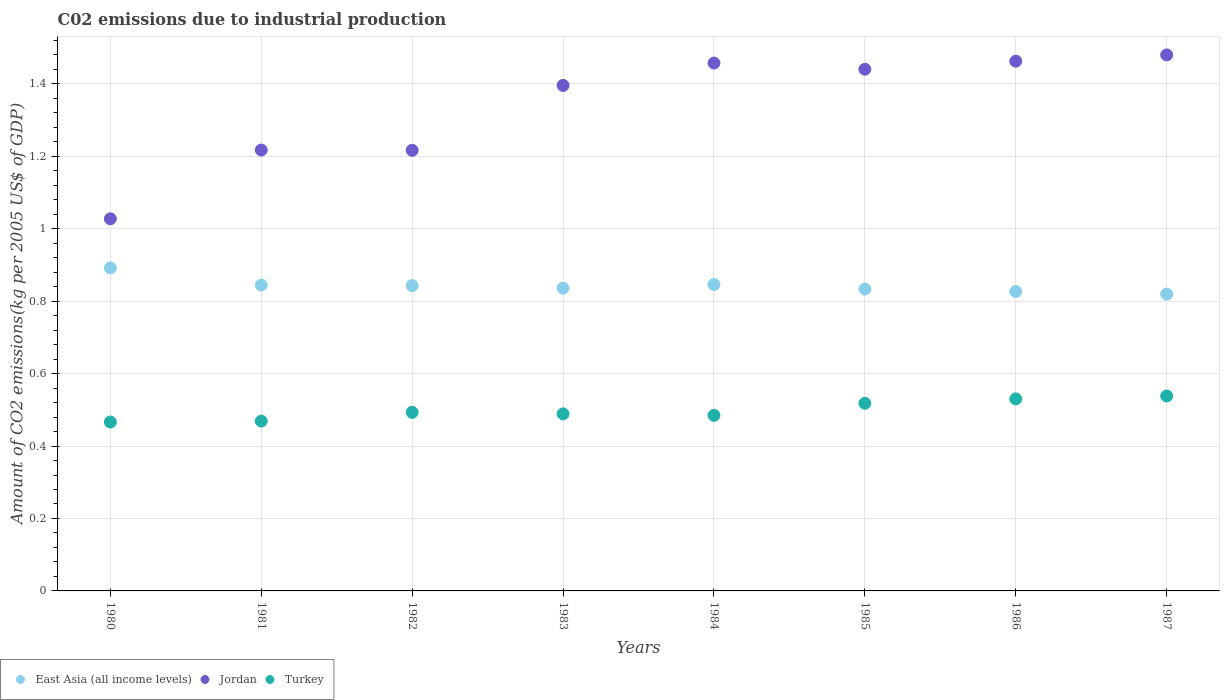How many different coloured dotlines are there?
Your answer should be very brief. 3. Is the number of dotlines equal to the number of legend labels?
Your response must be concise. Yes. What is the amount of CO2 emitted due to industrial production in Jordan in 1983?
Your answer should be very brief. 1.4. Across all years, what is the maximum amount of CO2 emitted due to industrial production in East Asia (all income levels)?
Offer a very short reply. 0.89. Across all years, what is the minimum amount of CO2 emitted due to industrial production in East Asia (all income levels)?
Make the answer very short. 0.82. In which year was the amount of CO2 emitted due to industrial production in Turkey minimum?
Provide a succinct answer. 1980. What is the total amount of CO2 emitted due to industrial production in Jordan in the graph?
Keep it short and to the point. 10.7. What is the difference between the amount of CO2 emitted due to industrial production in East Asia (all income levels) in 1982 and that in 1983?
Your response must be concise. 0.01. What is the difference between the amount of CO2 emitted due to industrial production in Jordan in 1986 and the amount of CO2 emitted due to industrial production in Turkey in 1980?
Make the answer very short. 1. What is the average amount of CO2 emitted due to industrial production in East Asia (all income levels) per year?
Provide a succinct answer. 0.84. In the year 1983, what is the difference between the amount of CO2 emitted due to industrial production in Jordan and amount of CO2 emitted due to industrial production in Turkey?
Offer a terse response. 0.91. What is the ratio of the amount of CO2 emitted due to industrial production in East Asia (all income levels) in 1982 to that in 1983?
Your answer should be compact. 1.01. What is the difference between the highest and the second highest amount of CO2 emitted due to industrial production in Jordan?
Provide a succinct answer. 0.02. What is the difference between the highest and the lowest amount of CO2 emitted due to industrial production in Jordan?
Give a very brief answer. 0.45. In how many years, is the amount of CO2 emitted due to industrial production in Jordan greater than the average amount of CO2 emitted due to industrial production in Jordan taken over all years?
Your answer should be very brief. 5. Does the amount of CO2 emitted due to industrial production in East Asia (all income levels) monotonically increase over the years?
Provide a succinct answer. No. Is the amount of CO2 emitted due to industrial production in East Asia (all income levels) strictly greater than the amount of CO2 emitted due to industrial production in Turkey over the years?
Keep it short and to the point. Yes. Is the amount of CO2 emitted due to industrial production in Turkey strictly less than the amount of CO2 emitted due to industrial production in Jordan over the years?
Ensure brevity in your answer.  Yes. Does the graph contain any zero values?
Ensure brevity in your answer.  No. Where does the legend appear in the graph?
Your answer should be very brief. Bottom left. How are the legend labels stacked?
Give a very brief answer. Horizontal. What is the title of the graph?
Your answer should be very brief. C02 emissions due to industrial production. What is the label or title of the Y-axis?
Offer a very short reply. Amount of CO2 emissions(kg per 2005 US$ of GDP). What is the Amount of CO2 emissions(kg per 2005 US$ of GDP) in East Asia (all income levels) in 1980?
Offer a terse response. 0.89. What is the Amount of CO2 emissions(kg per 2005 US$ of GDP) of Jordan in 1980?
Make the answer very short. 1.03. What is the Amount of CO2 emissions(kg per 2005 US$ of GDP) in Turkey in 1980?
Keep it short and to the point. 0.47. What is the Amount of CO2 emissions(kg per 2005 US$ of GDP) of East Asia (all income levels) in 1981?
Provide a succinct answer. 0.84. What is the Amount of CO2 emissions(kg per 2005 US$ of GDP) in Jordan in 1981?
Offer a very short reply. 1.22. What is the Amount of CO2 emissions(kg per 2005 US$ of GDP) in Turkey in 1981?
Offer a very short reply. 0.47. What is the Amount of CO2 emissions(kg per 2005 US$ of GDP) of East Asia (all income levels) in 1982?
Offer a terse response. 0.84. What is the Amount of CO2 emissions(kg per 2005 US$ of GDP) in Jordan in 1982?
Provide a succinct answer. 1.22. What is the Amount of CO2 emissions(kg per 2005 US$ of GDP) in Turkey in 1982?
Make the answer very short. 0.49. What is the Amount of CO2 emissions(kg per 2005 US$ of GDP) of East Asia (all income levels) in 1983?
Ensure brevity in your answer.  0.84. What is the Amount of CO2 emissions(kg per 2005 US$ of GDP) of Jordan in 1983?
Offer a very short reply. 1.4. What is the Amount of CO2 emissions(kg per 2005 US$ of GDP) in Turkey in 1983?
Provide a short and direct response. 0.49. What is the Amount of CO2 emissions(kg per 2005 US$ of GDP) in East Asia (all income levels) in 1984?
Ensure brevity in your answer.  0.85. What is the Amount of CO2 emissions(kg per 2005 US$ of GDP) in Jordan in 1984?
Make the answer very short. 1.46. What is the Amount of CO2 emissions(kg per 2005 US$ of GDP) in Turkey in 1984?
Provide a succinct answer. 0.48. What is the Amount of CO2 emissions(kg per 2005 US$ of GDP) in East Asia (all income levels) in 1985?
Keep it short and to the point. 0.83. What is the Amount of CO2 emissions(kg per 2005 US$ of GDP) of Jordan in 1985?
Make the answer very short. 1.44. What is the Amount of CO2 emissions(kg per 2005 US$ of GDP) of Turkey in 1985?
Your answer should be very brief. 0.52. What is the Amount of CO2 emissions(kg per 2005 US$ of GDP) in East Asia (all income levels) in 1986?
Your answer should be compact. 0.83. What is the Amount of CO2 emissions(kg per 2005 US$ of GDP) in Jordan in 1986?
Provide a succinct answer. 1.46. What is the Amount of CO2 emissions(kg per 2005 US$ of GDP) in Turkey in 1986?
Offer a very short reply. 0.53. What is the Amount of CO2 emissions(kg per 2005 US$ of GDP) in East Asia (all income levels) in 1987?
Your answer should be compact. 0.82. What is the Amount of CO2 emissions(kg per 2005 US$ of GDP) of Jordan in 1987?
Your answer should be compact. 1.48. What is the Amount of CO2 emissions(kg per 2005 US$ of GDP) of Turkey in 1987?
Offer a very short reply. 0.54. Across all years, what is the maximum Amount of CO2 emissions(kg per 2005 US$ of GDP) of East Asia (all income levels)?
Offer a very short reply. 0.89. Across all years, what is the maximum Amount of CO2 emissions(kg per 2005 US$ of GDP) in Jordan?
Offer a terse response. 1.48. Across all years, what is the maximum Amount of CO2 emissions(kg per 2005 US$ of GDP) in Turkey?
Offer a terse response. 0.54. Across all years, what is the minimum Amount of CO2 emissions(kg per 2005 US$ of GDP) of East Asia (all income levels)?
Your response must be concise. 0.82. Across all years, what is the minimum Amount of CO2 emissions(kg per 2005 US$ of GDP) of Jordan?
Give a very brief answer. 1.03. Across all years, what is the minimum Amount of CO2 emissions(kg per 2005 US$ of GDP) in Turkey?
Provide a succinct answer. 0.47. What is the total Amount of CO2 emissions(kg per 2005 US$ of GDP) in East Asia (all income levels) in the graph?
Offer a very short reply. 6.74. What is the total Amount of CO2 emissions(kg per 2005 US$ of GDP) of Jordan in the graph?
Provide a succinct answer. 10.7. What is the total Amount of CO2 emissions(kg per 2005 US$ of GDP) of Turkey in the graph?
Provide a short and direct response. 3.99. What is the difference between the Amount of CO2 emissions(kg per 2005 US$ of GDP) of East Asia (all income levels) in 1980 and that in 1981?
Your answer should be very brief. 0.05. What is the difference between the Amount of CO2 emissions(kg per 2005 US$ of GDP) of Jordan in 1980 and that in 1981?
Your answer should be compact. -0.19. What is the difference between the Amount of CO2 emissions(kg per 2005 US$ of GDP) in Turkey in 1980 and that in 1981?
Keep it short and to the point. -0. What is the difference between the Amount of CO2 emissions(kg per 2005 US$ of GDP) in East Asia (all income levels) in 1980 and that in 1982?
Your response must be concise. 0.05. What is the difference between the Amount of CO2 emissions(kg per 2005 US$ of GDP) of Jordan in 1980 and that in 1982?
Make the answer very short. -0.19. What is the difference between the Amount of CO2 emissions(kg per 2005 US$ of GDP) in Turkey in 1980 and that in 1982?
Your response must be concise. -0.03. What is the difference between the Amount of CO2 emissions(kg per 2005 US$ of GDP) of East Asia (all income levels) in 1980 and that in 1983?
Your answer should be compact. 0.06. What is the difference between the Amount of CO2 emissions(kg per 2005 US$ of GDP) in Jordan in 1980 and that in 1983?
Keep it short and to the point. -0.37. What is the difference between the Amount of CO2 emissions(kg per 2005 US$ of GDP) in Turkey in 1980 and that in 1983?
Your answer should be very brief. -0.02. What is the difference between the Amount of CO2 emissions(kg per 2005 US$ of GDP) in East Asia (all income levels) in 1980 and that in 1984?
Make the answer very short. 0.05. What is the difference between the Amount of CO2 emissions(kg per 2005 US$ of GDP) in Jordan in 1980 and that in 1984?
Provide a short and direct response. -0.43. What is the difference between the Amount of CO2 emissions(kg per 2005 US$ of GDP) of Turkey in 1980 and that in 1984?
Offer a very short reply. -0.02. What is the difference between the Amount of CO2 emissions(kg per 2005 US$ of GDP) of East Asia (all income levels) in 1980 and that in 1985?
Ensure brevity in your answer.  0.06. What is the difference between the Amount of CO2 emissions(kg per 2005 US$ of GDP) of Jordan in 1980 and that in 1985?
Ensure brevity in your answer.  -0.41. What is the difference between the Amount of CO2 emissions(kg per 2005 US$ of GDP) in Turkey in 1980 and that in 1985?
Your answer should be very brief. -0.05. What is the difference between the Amount of CO2 emissions(kg per 2005 US$ of GDP) in East Asia (all income levels) in 1980 and that in 1986?
Provide a short and direct response. 0.07. What is the difference between the Amount of CO2 emissions(kg per 2005 US$ of GDP) in Jordan in 1980 and that in 1986?
Offer a very short reply. -0.44. What is the difference between the Amount of CO2 emissions(kg per 2005 US$ of GDP) in Turkey in 1980 and that in 1986?
Offer a very short reply. -0.06. What is the difference between the Amount of CO2 emissions(kg per 2005 US$ of GDP) of East Asia (all income levels) in 1980 and that in 1987?
Your response must be concise. 0.07. What is the difference between the Amount of CO2 emissions(kg per 2005 US$ of GDP) in Jordan in 1980 and that in 1987?
Ensure brevity in your answer.  -0.45. What is the difference between the Amount of CO2 emissions(kg per 2005 US$ of GDP) of Turkey in 1980 and that in 1987?
Ensure brevity in your answer.  -0.07. What is the difference between the Amount of CO2 emissions(kg per 2005 US$ of GDP) of East Asia (all income levels) in 1981 and that in 1982?
Offer a terse response. 0. What is the difference between the Amount of CO2 emissions(kg per 2005 US$ of GDP) of Jordan in 1981 and that in 1982?
Offer a terse response. 0. What is the difference between the Amount of CO2 emissions(kg per 2005 US$ of GDP) of Turkey in 1981 and that in 1982?
Your answer should be compact. -0.02. What is the difference between the Amount of CO2 emissions(kg per 2005 US$ of GDP) of East Asia (all income levels) in 1981 and that in 1983?
Make the answer very short. 0.01. What is the difference between the Amount of CO2 emissions(kg per 2005 US$ of GDP) in Jordan in 1981 and that in 1983?
Provide a succinct answer. -0.18. What is the difference between the Amount of CO2 emissions(kg per 2005 US$ of GDP) of Turkey in 1981 and that in 1983?
Your answer should be compact. -0.02. What is the difference between the Amount of CO2 emissions(kg per 2005 US$ of GDP) in East Asia (all income levels) in 1981 and that in 1984?
Your response must be concise. -0. What is the difference between the Amount of CO2 emissions(kg per 2005 US$ of GDP) of Jordan in 1981 and that in 1984?
Offer a very short reply. -0.24. What is the difference between the Amount of CO2 emissions(kg per 2005 US$ of GDP) of Turkey in 1981 and that in 1984?
Provide a short and direct response. -0.02. What is the difference between the Amount of CO2 emissions(kg per 2005 US$ of GDP) in East Asia (all income levels) in 1981 and that in 1985?
Give a very brief answer. 0.01. What is the difference between the Amount of CO2 emissions(kg per 2005 US$ of GDP) in Jordan in 1981 and that in 1985?
Your answer should be very brief. -0.22. What is the difference between the Amount of CO2 emissions(kg per 2005 US$ of GDP) in Turkey in 1981 and that in 1985?
Offer a terse response. -0.05. What is the difference between the Amount of CO2 emissions(kg per 2005 US$ of GDP) in East Asia (all income levels) in 1981 and that in 1986?
Ensure brevity in your answer.  0.02. What is the difference between the Amount of CO2 emissions(kg per 2005 US$ of GDP) in Jordan in 1981 and that in 1986?
Ensure brevity in your answer.  -0.25. What is the difference between the Amount of CO2 emissions(kg per 2005 US$ of GDP) of Turkey in 1981 and that in 1986?
Ensure brevity in your answer.  -0.06. What is the difference between the Amount of CO2 emissions(kg per 2005 US$ of GDP) of East Asia (all income levels) in 1981 and that in 1987?
Provide a succinct answer. 0.02. What is the difference between the Amount of CO2 emissions(kg per 2005 US$ of GDP) in Jordan in 1981 and that in 1987?
Offer a very short reply. -0.26. What is the difference between the Amount of CO2 emissions(kg per 2005 US$ of GDP) in Turkey in 1981 and that in 1987?
Your answer should be compact. -0.07. What is the difference between the Amount of CO2 emissions(kg per 2005 US$ of GDP) in East Asia (all income levels) in 1982 and that in 1983?
Your answer should be very brief. 0.01. What is the difference between the Amount of CO2 emissions(kg per 2005 US$ of GDP) in Jordan in 1982 and that in 1983?
Your response must be concise. -0.18. What is the difference between the Amount of CO2 emissions(kg per 2005 US$ of GDP) of Turkey in 1982 and that in 1983?
Keep it short and to the point. 0. What is the difference between the Amount of CO2 emissions(kg per 2005 US$ of GDP) of East Asia (all income levels) in 1982 and that in 1984?
Offer a very short reply. -0. What is the difference between the Amount of CO2 emissions(kg per 2005 US$ of GDP) of Jordan in 1982 and that in 1984?
Your answer should be very brief. -0.24. What is the difference between the Amount of CO2 emissions(kg per 2005 US$ of GDP) of Turkey in 1982 and that in 1984?
Keep it short and to the point. 0.01. What is the difference between the Amount of CO2 emissions(kg per 2005 US$ of GDP) of East Asia (all income levels) in 1982 and that in 1985?
Your response must be concise. 0.01. What is the difference between the Amount of CO2 emissions(kg per 2005 US$ of GDP) of Jordan in 1982 and that in 1985?
Your response must be concise. -0.22. What is the difference between the Amount of CO2 emissions(kg per 2005 US$ of GDP) of Turkey in 1982 and that in 1985?
Your answer should be very brief. -0.03. What is the difference between the Amount of CO2 emissions(kg per 2005 US$ of GDP) in East Asia (all income levels) in 1982 and that in 1986?
Your answer should be very brief. 0.02. What is the difference between the Amount of CO2 emissions(kg per 2005 US$ of GDP) in Jordan in 1982 and that in 1986?
Offer a terse response. -0.25. What is the difference between the Amount of CO2 emissions(kg per 2005 US$ of GDP) in Turkey in 1982 and that in 1986?
Your answer should be very brief. -0.04. What is the difference between the Amount of CO2 emissions(kg per 2005 US$ of GDP) in East Asia (all income levels) in 1982 and that in 1987?
Your answer should be very brief. 0.02. What is the difference between the Amount of CO2 emissions(kg per 2005 US$ of GDP) of Jordan in 1982 and that in 1987?
Your answer should be compact. -0.26. What is the difference between the Amount of CO2 emissions(kg per 2005 US$ of GDP) of Turkey in 1982 and that in 1987?
Provide a short and direct response. -0.05. What is the difference between the Amount of CO2 emissions(kg per 2005 US$ of GDP) in East Asia (all income levels) in 1983 and that in 1984?
Provide a succinct answer. -0.01. What is the difference between the Amount of CO2 emissions(kg per 2005 US$ of GDP) in Jordan in 1983 and that in 1984?
Provide a succinct answer. -0.06. What is the difference between the Amount of CO2 emissions(kg per 2005 US$ of GDP) of Turkey in 1983 and that in 1984?
Provide a short and direct response. 0. What is the difference between the Amount of CO2 emissions(kg per 2005 US$ of GDP) in East Asia (all income levels) in 1983 and that in 1985?
Give a very brief answer. 0. What is the difference between the Amount of CO2 emissions(kg per 2005 US$ of GDP) of Jordan in 1983 and that in 1985?
Your answer should be compact. -0.04. What is the difference between the Amount of CO2 emissions(kg per 2005 US$ of GDP) in Turkey in 1983 and that in 1985?
Offer a very short reply. -0.03. What is the difference between the Amount of CO2 emissions(kg per 2005 US$ of GDP) of East Asia (all income levels) in 1983 and that in 1986?
Offer a very short reply. 0.01. What is the difference between the Amount of CO2 emissions(kg per 2005 US$ of GDP) of Jordan in 1983 and that in 1986?
Offer a terse response. -0.07. What is the difference between the Amount of CO2 emissions(kg per 2005 US$ of GDP) of Turkey in 1983 and that in 1986?
Make the answer very short. -0.04. What is the difference between the Amount of CO2 emissions(kg per 2005 US$ of GDP) of East Asia (all income levels) in 1983 and that in 1987?
Offer a very short reply. 0.02. What is the difference between the Amount of CO2 emissions(kg per 2005 US$ of GDP) of Jordan in 1983 and that in 1987?
Your answer should be very brief. -0.08. What is the difference between the Amount of CO2 emissions(kg per 2005 US$ of GDP) of Turkey in 1983 and that in 1987?
Provide a succinct answer. -0.05. What is the difference between the Amount of CO2 emissions(kg per 2005 US$ of GDP) of East Asia (all income levels) in 1984 and that in 1985?
Give a very brief answer. 0.01. What is the difference between the Amount of CO2 emissions(kg per 2005 US$ of GDP) in Jordan in 1984 and that in 1985?
Provide a short and direct response. 0.02. What is the difference between the Amount of CO2 emissions(kg per 2005 US$ of GDP) in Turkey in 1984 and that in 1985?
Offer a terse response. -0.03. What is the difference between the Amount of CO2 emissions(kg per 2005 US$ of GDP) in East Asia (all income levels) in 1984 and that in 1986?
Give a very brief answer. 0.02. What is the difference between the Amount of CO2 emissions(kg per 2005 US$ of GDP) of Jordan in 1984 and that in 1986?
Your answer should be compact. -0.01. What is the difference between the Amount of CO2 emissions(kg per 2005 US$ of GDP) in Turkey in 1984 and that in 1986?
Your answer should be compact. -0.05. What is the difference between the Amount of CO2 emissions(kg per 2005 US$ of GDP) in East Asia (all income levels) in 1984 and that in 1987?
Your response must be concise. 0.03. What is the difference between the Amount of CO2 emissions(kg per 2005 US$ of GDP) in Jordan in 1984 and that in 1987?
Your answer should be very brief. -0.02. What is the difference between the Amount of CO2 emissions(kg per 2005 US$ of GDP) of Turkey in 1984 and that in 1987?
Your response must be concise. -0.05. What is the difference between the Amount of CO2 emissions(kg per 2005 US$ of GDP) in East Asia (all income levels) in 1985 and that in 1986?
Offer a very short reply. 0.01. What is the difference between the Amount of CO2 emissions(kg per 2005 US$ of GDP) in Jordan in 1985 and that in 1986?
Your response must be concise. -0.02. What is the difference between the Amount of CO2 emissions(kg per 2005 US$ of GDP) of Turkey in 1985 and that in 1986?
Ensure brevity in your answer.  -0.01. What is the difference between the Amount of CO2 emissions(kg per 2005 US$ of GDP) of East Asia (all income levels) in 1985 and that in 1987?
Make the answer very short. 0.01. What is the difference between the Amount of CO2 emissions(kg per 2005 US$ of GDP) in Jordan in 1985 and that in 1987?
Keep it short and to the point. -0.04. What is the difference between the Amount of CO2 emissions(kg per 2005 US$ of GDP) in Turkey in 1985 and that in 1987?
Give a very brief answer. -0.02. What is the difference between the Amount of CO2 emissions(kg per 2005 US$ of GDP) in East Asia (all income levels) in 1986 and that in 1987?
Give a very brief answer. 0.01. What is the difference between the Amount of CO2 emissions(kg per 2005 US$ of GDP) of Jordan in 1986 and that in 1987?
Give a very brief answer. -0.02. What is the difference between the Amount of CO2 emissions(kg per 2005 US$ of GDP) in Turkey in 1986 and that in 1987?
Your answer should be very brief. -0.01. What is the difference between the Amount of CO2 emissions(kg per 2005 US$ of GDP) of East Asia (all income levels) in 1980 and the Amount of CO2 emissions(kg per 2005 US$ of GDP) of Jordan in 1981?
Give a very brief answer. -0.33. What is the difference between the Amount of CO2 emissions(kg per 2005 US$ of GDP) of East Asia (all income levels) in 1980 and the Amount of CO2 emissions(kg per 2005 US$ of GDP) of Turkey in 1981?
Provide a succinct answer. 0.42. What is the difference between the Amount of CO2 emissions(kg per 2005 US$ of GDP) in Jordan in 1980 and the Amount of CO2 emissions(kg per 2005 US$ of GDP) in Turkey in 1981?
Ensure brevity in your answer.  0.56. What is the difference between the Amount of CO2 emissions(kg per 2005 US$ of GDP) in East Asia (all income levels) in 1980 and the Amount of CO2 emissions(kg per 2005 US$ of GDP) in Jordan in 1982?
Your answer should be very brief. -0.32. What is the difference between the Amount of CO2 emissions(kg per 2005 US$ of GDP) of East Asia (all income levels) in 1980 and the Amount of CO2 emissions(kg per 2005 US$ of GDP) of Turkey in 1982?
Give a very brief answer. 0.4. What is the difference between the Amount of CO2 emissions(kg per 2005 US$ of GDP) of Jordan in 1980 and the Amount of CO2 emissions(kg per 2005 US$ of GDP) of Turkey in 1982?
Your response must be concise. 0.53. What is the difference between the Amount of CO2 emissions(kg per 2005 US$ of GDP) in East Asia (all income levels) in 1980 and the Amount of CO2 emissions(kg per 2005 US$ of GDP) in Jordan in 1983?
Your answer should be very brief. -0.5. What is the difference between the Amount of CO2 emissions(kg per 2005 US$ of GDP) in East Asia (all income levels) in 1980 and the Amount of CO2 emissions(kg per 2005 US$ of GDP) in Turkey in 1983?
Ensure brevity in your answer.  0.4. What is the difference between the Amount of CO2 emissions(kg per 2005 US$ of GDP) in Jordan in 1980 and the Amount of CO2 emissions(kg per 2005 US$ of GDP) in Turkey in 1983?
Your answer should be compact. 0.54. What is the difference between the Amount of CO2 emissions(kg per 2005 US$ of GDP) of East Asia (all income levels) in 1980 and the Amount of CO2 emissions(kg per 2005 US$ of GDP) of Jordan in 1984?
Offer a terse response. -0.57. What is the difference between the Amount of CO2 emissions(kg per 2005 US$ of GDP) of East Asia (all income levels) in 1980 and the Amount of CO2 emissions(kg per 2005 US$ of GDP) of Turkey in 1984?
Keep it short and to the point. 0.41. What is the difference between the Amount of CO2 emissions(kg per 2005 US$ of GDP) in Jordan in 1980 and the Amount of CO2 emissions(kg per 2005 US$ of GDP) in Turkey in 1984?
Provide a short and direct response. 0.54. What is the difference between the Amount of CO2 emissions(kg per 2005 US$ of GDP) of East Asia (all income levels) in 1980 and the Amount of CO2 emissions(kg per 2005 US$ of GDP) of Jordan in 1985?
Give a very brief answer. -0.55. What is the difference between the Amount of CO2 emissions(kg per 2005 US$ of GDP) in East Asia (all income levels) in 1980 and the Amount of CO2 emissions(kg per 2005 US$ of GDP) in Turkey in 1985?
Your answer should be compact. 0.37. What is the difference between the Amount of CO2 emissions(kg per 2005 US$ of GDP) in Jordan in 1980 and the Amount of CO2 emissions(kg per 2005 US$ of GDP) in Turkey in 1985?
Your answer should be very brief. 0.51. What is the difference between the Amount of CO2 emissions(kg per 2005 US$ of GDP) of East Asia (all income levels) in 1980 and the Amount of CO2 emissions(kg per 2005 US$ of GDP) of Jordan in 1986?
Your answer should be very brief. -0.57. What is the difference between the Amount of CO2 emissions(kg per 2005 US$ of GDP) of East Asia (all income levels) in 1980 and the Amount of CO2 emissions(kg per 2005 US$ of GDP) of Turkey in 1986?
Your answer should be very brief. 0.36. What is the difference between the Amount of CO2 emissions(kg per 2005 US$ of GDP) in Jordan in 1980 and the Amount of CO2 emissions(kg per 2005 US$ of GDP) in Turkey in 1986?
Provide a succinct answer. 0.5. What is the difference between the Amount of CO2 emissions(kg per 2005 US$ of GDP) in East Asia (all income levels) in 1980 and the Amount of CO2 emissions(kg per 2005 US$ of GDP) in Jordan in 1987?
Make the answer very short. -0.59. What is the difference between the Amount of CO2 emissions(kg per 2005 US$ of GDP) of East Asia (all income levels) in 1980 and the Amount of CO2 emissions(kg per 2005 US$ of GDP) of Turkey in 1987?
Your answer should be compact. 0.35. What is the difference between the Amount of CO2 emissions(kg per 2005 US$ of GDP) of Jordan in 1980 and the Amount of CO2 emissions(kg per 2005 US$ of GDP) of Turkey in 1987?
Your answer should be compact. 0.49. What is the difference between the Amount of CO2 emissions(kg per 2005 US$ of GDP) in East Asia (all income levels) in 1981 and the Amount of CO2 emissions(kg per 2005 US$ of GDP) in Jordan in 1982?
Ensure brevity in your answer.  -0.37. What is the difference between the Amount of CO2 emissions(kg per 2005 US$ of GDP) of East Asia (all income levels) in 1981 and the Amount of CO2 emissions(kg per 2005 US$ of GDP) of Turkey in 1982?
Ensure brevity in your answer.  0.35. What is the difference between the Amount of CO2 emissions(kg per 2005 US$ of GDP) in Jordan in 1981 and the Amount of CO2 emissions(kg per 2005 US$ of GDP) in Turkey in 1982?
Your answer should be very brief. 0.72. What is the difference between the Amount of CO2 emissions(kg per 2005 US$ of GDP) in East Asia (all income levels) in 1981 and the Amount of CO2 emissions(kg per 2005 US$ of GDP) in Jordan in 1983?
Give a very brief answer. -0.55. What is the difference between the Amount of CO2 emissions(kg per 2005 US$ of GDP) of East Asia (all income levels) in 1981 and the Amount of CO2 emissions(kg per 2005 US$ of GDP) of Turkey in 1983?
Keep it short and to the point. 0.36. What is the difference between the Amount of CO2 emissions(kg per 2005 US$ of GDP) of Jordan in 1981 and the Amount of CO2 emissions(kg per 2005 US$ of GDP) of Turkey in 1983?
Ensure brevity in your answer.  0.73. What is the difference between the Amount of CO2 emissions(kg per 2005 US$ of GDP) of East Asia (all income levels) in 1981 and the Amount of CO2 emissions(kg per 2005 US$ of GDP) of Jordan in 1984?
Offer a very short reply. -0.61. What is the difference between the Amount of CO2 emissions(kg per 2005 US$ of GDP) in East Asia (all income levels) in 1981 and the Amount of CO2 emissions(kg per 2005 US$ of GDP) in Turkey in 1984?
Provide a succinct answer. 0.36. What is the difference between the Amount of CO2 emissions(kg per 2005 US$ of GDP) in Jordan in 1981 and the Amount of CO2 emissions(kg per 2005 US$ of GDP) in Turkey in 1984?
Give a very brief answer. 0.73. What is the difference between the Amount of CO2 emissions(kg per 2005 US$ of GDP) of East Asia (all income levels) in 1981 and the Amount of CO2 emissions(kg per 2005 US$ of GDP) of Jordan in 1985?
Provide a short and direct response. -0.6. What is the difference between the Amount of CO2 emissions(kg per 2005 US$ of GDP) in East Asia (all income levels) in 1981 and the Amount of CO2 emissions(kg per 2005 US$ of GDP) in Turkey in 1985?
Keep it short and to the point. 0.33. What is the difference between the Amount of CO2 emissions(kg per 2005 US$ of GDP) of Jordan in 1981 and the Amount of CO2 emissions(kg per 2005 US$ of GDP) of Turkey in 1985?
Keep it short and to the point. 0.7. What is the difference between the Amount of CO2 emissions(kg per 2005 US$ of GDP) of East Asia (all income levels) in 1981 and the Amount of CO2 emissions(kg per 2005 US$ of GDP) of Jordan in 1986?
Your answer should be compact. -0.62. What is the difference between the Amount of CO2 emissions(kg per 2005 US$ of GDP) of East Asia (all income levels) in 1981 and the Amount of CO2 emissions(kg per 2005 US$ of GDP) of Turkey in 1986?
Give a very brief answer. 0.31. What is the difference between the Amount of CO2 emissions(kg per 2005 US$ of GDP) of Jordan in 1981 and the Amount of CO2 emissions(kg per 2005 US$ of GDP) of Turkey in 1986?
Ensure brevity in your answer.  0.69. What is the difference between the Amount of CO2 emissions(kg per 2005 US$ of GDP) in East Asia (all income levels) in 1981 and the Amount of CO2 emissions(kg per 2005 US$ of GDP) in Jordan in 1987?
Your response must be concise. -0.64. What is the difference between the Amount of CO2 emissions(kg per 2005 US$ of GDP) of East Asia (all income levels) in 1981 and the Amount of CO2 emissions(kg per 2005 US$ of GDP) of Turkey in 1987?
Your answer should be very brief. 0.31. What is the difference between the Amount of CO2 emissions(kg per 2005 US$ of GDP) in Jordan in 1981 and the Amount of CO2 emissions(kg per 2005 US$ of GDP) in Turkey in 1987?
Give a very brief answer. 0.68. What is the difference between the Amount of CO2 emissions(kg per 2005 US$ of GDP) of East Asia (all income levels) in 1982 and the Amount of CO2 emissions(kg per 2005 US$ of GDP) of Jordan in 1983?
Offer a terse response. -0.55. What is the difference between the Amount of CO2 emissions(kg per 2005 US$ of GDP) in East Asia (all income levels) in 1982 and the Amount of CO2 emissions(kg per 2005 US$ of GDP) in Turkey in 1983?
Provide a succinct answer. 0.35. What is the difference between the Amount of CO2 emissions(kg per 2005 US$ of GDP) in Jordan in 1982 and the Amount of CO2 emissions(kg per 2005 US$ of GDP) in Turkey in 1983?
Your answer should be compact. 0.73. What is the difference between the Amount of CO2 emissions(kg per 2005 US$ of GDP) of East Asia (all income levels) in 1982 and the Amount of CO2 emissions(kg per 2005 US$ of GDP) of Jordan in 1984?
Offer a very short reply. -0.61. What is the difference between the Amount of CO2 emissions(kg per 2005 US$ of GDP) in East Asia (all income levels) in 1982 and the Amount of CO2 emissions(kg per 2005 US$ of GDP) in Turkey in 1984?
Ensure brevity in your answer.  0.36. What is the difference between the Amount of CO2 emissions(kg per 2005 US$ of GDP) in Jordan in 1982 and the Amount of CO2 emissions(kg per 2005 US$ of GDP) in Turkey in 1984?
Offer a very short reply. 0.73. What is the difference between the Amount of CO2 emissions(kg per 2005 US$ of GDP) of East Asia (all income levels) in 1982 and the Amount of CO2 emissions(kg per 2005 US$ of GDP) of Jordan in 1985?
Provide a succinct answer. -0.6. What is the difference between the Amount of CO2 emissions(kg per 2005 US$ of GDP) of East Asia (all income levels) in 1982 and the Amount of CO2 emissions(kg per 2005 US$ of GDP) of Turkey in 1985?
Ensure brevity in your answer.  0.32. What is the difference between the Amount of CO2 emissions(kg per 2005 US$ of GDP) of Jordan in 1982 and the Amount of CO2 emissions(kg per 2005 US$ of GDP) of Turkey in 1985?
Make the answer very short. 0.7. What is the difference between the Amount of CO2 emissions(kg per 2005 US$ of GDP) of East Asia (all income levels) in 1982 and the Amount of CO2 emissions(kg per 2005 US$ of GDP) of Jordan in 1986?
Provide a succinct answer. -0.62. What is the difference between the Amount of CO2 emissions(kg per 2005 US$ of GDP) of East Asia (all income levels) in 1982 and the Amount of CO2 emissions(kg per 2005 US$ of GDP) of Turkey in 1986?
Your response must be concise. 0.31. What is the difference between the Amount of CO2 emissions(kg per 2005 US$ of GDP) in Jordan in 1982 and the Amount of CO2 emissions(kg per 2005 US$ of GDP) in Turkey in 1986?
Offer a terse response. 0.69. What is the difference between the Amount of CO2 emissions(kg per 2005 US$ of GDP) in East Asia (all income levels) in 1982 and the Amount of CO2 emissions(kg per 2005 US$ of GDP) in Jordan in 1987?
Make the answer very short. -0.64. What is the difference between the Amount of CO2 emissions(kg per 2005 US$ of GDP) in East Asia (all income levels) in 1982 and the Amount of CO2 emissions(kg per 2005 US$ of GDP) in Turkey in 1987?
Your answer should be very brief. 0.3. What is the difference between the Amount of CO2 emissions(kg per 2005 US$ of GDP) of Jordan in 1982 and the Amount of CO2 emissions(kg per 2005 US$ of GDP) of Turkey in 1987?
Ensure brevity in your answer.  0.68. What is the difference between the Amount of CO2 emissions(kg per 2005 US$ of GDP) of East Asia (all income levels) in 1983 and the Amount of CO2 emissions(kg per 2005 US$ of GDP) of Jordan in 1984?
Provide a succinct answer. -0.62. What is the difference between the Amount of CO2 emissions(kg per 2005 US$ of GDP) in East Asia (all income levels) in 1983 and the Amount of CO2 emissions(kg per 2005 US$ of GDP) in Turkey in 1984?
Your answer should be compact. 0.35. What is the difference between the Amount of CO2 emissions(kg per 2005 US$ of GDP) in Jordan in 1983 and the Amount of CO2 emissions(kg per 2005 US$ of GDP) in Turkey in 1984?
Offer a terse response. 0.91. What is the difference between the Amount of CO2 emissions(kg per 2005 US$ of GDP) in East Asia (all income levels) in 1983 and the Amount of CO2 emissions(kg per 2005 US$ of GDP) in Jordan in 1985?
Ensure brevity in your answer.  -0.6. What is the difference between the Amount of CO2 emissions(kg per 2005 US$ of GDP) in East Asia (all income levels) in 1983 and the Amount of CO2 emissions(kg per 2005 US$ of GDP) in Turkey in 1985?
Ensure brevity in your answer.  0.32. What is the difference between the Amount of CO2 emissions(kg per 2005 US$ of GDP) in Jordan in 1983 and the Amount of CO2 emissions(kg per 2005 US$ of GDP) in Turkey in 1985?
Make the answer very short. 0.88. What is the difference between the Amount of CO2 emissions(kg per 2005 US$ of GDP) of East Asia (all income levels) in 1983 and the Amount of CO2 emissions(kg per 2005 US$ of GDP) of Jordan in 1986?
Keep it short and to the point. -0.63. What is the difference between the Amount of CO2 emissions(kg per 2005 US$ of GDP) of East Asia (all income levels) in 1983 and the Amount of CO2 emissions(kg per 2005 US$ of GDP) of Turkey in 1986?
Your response must be concise. 0.31. What is the difference between the Amount of CO2 emissions(kg per 2005 US$ of GDP) of Jordan in 1983 and the Amount of CO2 emissions(kg per 2005 US$ of GDP) of Turkey in 1986?
Offer a very short reply. 0.87. What is the difference between the Amount of CO2 emissions(kg per 2005 US$ of GDP) in East Asia (all income levels) in 1983 and the Amount of CO2 emissions(kg per 2005 US$ of GDP) in Jordan in 1987?
Your response must be concise. -0.64. What is the difference between the Amount of CO2 emissions(kg per 2005 US$ of GDP) in East Asia (all income levels) in 1983 and the Amount of CO2 emissions(kg per 2005 US$ of GDP) in Turkey in 1987?
Offer a terse response. 0.3. What is the difference between the Amount of CO2 emissions(kg per 2005 US$ of GDP) in Jordan in 1983 and the Amount of CO2 emissions(kg per 2005 US$ of GDP) in Turkey in 1987?
Ensure brevity in your answer.  0.86. What is the difference between the Amount of CO2 emissions(kg per 2005 US$ of GDP) in East Asia (all income levels) in 1984 and the Amount of CO2 emissions(kg per 2005 US$ of GDP) in Jordan in 1985?
Provide a short and direct response. -0.59. What is the difference between the Amount of CO2 emissions(kg per 2005 US$ of GDP) in East Asia (all income levels) in 1984 and the Amount of CO2 emissions(kg per 2005 US$ of GDP) in Turkey in 1985?
Keep it short and to the point. 0.33. What is the difference between the Amount of CO2 emissions(kg per 2005 US$ of GDP) of Jordan in 1984 and the Amount of CO2 emissions(kg per 2005 US$ of GDP) of Turkey in 1985?
Keep it short and to the point. 0.94. What is the difference between the Amount of CO2 emissions(kg per 2005 US$ of GDP) of East Asia (all income levels) in 1984 and the Amount of CO2 emissions(kg per 2005 US$ of GDP) of Jordan in 1986?
Offer a terse response. -0.62. What is the difference between the Amount of CO2 emissions(kg per 2005 US$ of GDP) of East Asia (all income levels) in 1984 and the Amount of CO2 emissions(kg per 2005 US$ of GDP) of Turkey in 1986?
Make the answer very short. 0.32. What is the difference between the Amount of CO2 emissions(kg per 2005 US$ of GDP) of Jordan in 1984 and the Amount of CO2 emissions(kg per 2005 US$ of GDP) of Turkey in 1986?
Provide a short and direct response. 0.93. What is the difference between the Amount of CO2 emissions(kg per 2005 US$ of GDP) in East Asia (all income levels) in 1984 and the Amount of CO2 emissions(kg per 2005 US$ of GDP) in Jordan in 1987?
Your response must be concise. -0.63. What is the difference between the Amount of CO2 emissions(kg per 2005 US$ of GDP) of East Asia (all income levels) in 1984 and the Amount of CO2 emissions(kg per 2005 US$ of GDP) of Turkey in 1987?
Keep it short and to the point. 0.31. What is the difference between the Amount of CO2 emissions(kg per 2005 US$ of GDP) of Jordan in 1984 and the Amount of CO2 emissions(kg per 2005 US$ of GDP) of Turkey in 1987?
Give a very brief answer. 0.92. What is the difference between the Amount of CO2 emissions(kg per 2005 US$ of GDP) of East Asia (all income levels) in 1985 and the Amount of CO2 emissions(kg per 2005 US$ of GDP) of Jordan in 1986?
Your answer should be very brief. -0.63. What is the difference between the Amount of CO2 emissions(kg per 2005 US$ of GDP) in East Asia (all income levels) in 1985 and the Amount of CO2 emissions(kg per 2005 US$ of GDP) in Turkey in 1986?
Your answer should be compact. 0.3. What is the difference between the Amount of CO2 emissions(kg per 2005 US$ of GDP) of Jordan in 1985 and the Amount of CO2 emissions(kg per 2005 US$ of GDP) of Turkey in 1986?
Offer a very short reply. 0.91. What is the difference between the Amount of CO2 emissions(kg per 2005 US$ of GDP) in East Asia (all income levels) in 1985 and the Amount of CO2 emissions(kg per 2005 US$ of GDP) in Jordan in 1987?
Your response must be concise. -0.65. What is the difference between the Amount of CO2 emissions(kg per 2005 US$ of GDP) of East Asia (all income levels) in 1985 and the Amount of CO2 emissions(kg per 2005 US$ of GDP) of Turkey in 1987?
Give a very brief answer. 0.3. What is the difference between the Amount of CO2 emissions(kg per 2005 US$ of GDP) in Jordan in 1985 and the Amount of CO2 emissions(kg per 2005 US$ of GDP) in Turkey in 1987?
Offer a very short reply. 0.9. What is the difference between the Amount of CO2 emissions(kg per 2005 US$ of GDP) in East Asia (all income levels) in 1986 and the Amount of CO2 emissions(kg per 2005 US$ of GDP) in Jordan in 1987?
Your response must be concise. -0.65. What is the difference between the Amount of CO2 emissions(kg per 2005 US$ of GDP) in East Asia (all income levels) in 1986 and the Amount of CO2 emissions(kg per 2005 US$ of GDP) in Turkey in 1987?
Give a very brief answer. 0.29. What is the difference between the Amount of CO2 emissions(kg per 2005 US$ of GDP) in Jordan in 1986 and the Amount of CO2 emissions(kg per 2005 US$ of GDP) in Turkey in 1987?
Your answer should be compact. 0.92. What is the average Amount of CO2 emissions(kg per 2005 US$ of GDP) in East Asia (all income levels) per year?
Your response must be concise. 0.84. What is the average Amount of CO2 emissions(kg per 2005 US$ of GDP) of Jordan per year?
Make the answer very short. 1.34. What is the average Amount of CO2 emissions(kg per 2005 US$ of GDP) of Turkey per year?
Provide a succinct answer. 0.5. In the year 1980, what is the difference between the Amount of CO2 emissions(kg per 2005 US$ of GDP) of East Asia (all income levels) and Amount of CO2 emissions(kg per 2005 US$ of GDP) of Jordan?
Offer a terse response. -0.14. In the year 1980, what is the difference between the Amount of CO2 emissions(kg per 2005 US$ of GDP) of East Asia (all income levels) and Amount of CO2 emissions(kg per 2005 US$ of GDP) of Turkey?
Your answer should be compact. 0.43. In the year 1980, what is the difference between the Amount of CO2 emissions(kg per 2005 US$ of GDP) of Jordan and Amount of CO2 emissions(kg per 2005 US$ of GDP) of Turkey?
Offer a very short reply. 0.56. In the year 1981, what is the difference between the Amount of CO2 emissions(kg per 2005 US$ of GDP) in East Asia (all income levels) and Amount of CO2 emissions(kg per 2005 US$ of GDP) in Jordan?
Your answer should be very brief. -0.37. In the year 1981, what is the difference between the Amount of CO2 emissions(kg per 2005 US$ of GDP) of East Asia (all income levels) and Amount of CO2 emissions(kg per 2005 US$ of GDP) of Turkey?
Give a very brief answer. 0.38. In the year 1981, what is the difference between the Amount of CO2 emissions(kg per 2005 US$ of GDP) of Jordan and Amount of CO2 emissions(kg per 2005 US$ of GDP) of Turkey?
Offer a very short reply. 0.75. In the year 1982, what is the difference between the Amount of CO2 emissions(kg per 2005 US$ of GDP) in East Asia (all income levels) and Amount of CO2 emissions(kg per 2005 US$ of GDP) in Jordan?
Your response must be concise. -0.37. In the year 1982, what is the difference between the Amount of CO2 emissions(kg per 2005 US$ of GDP) in East Asia (all income levels) and Amount of CO2 emissions(kg per 2005 US$ of GDP) in Turkey?
Provide a short and direct response. 0.35. In the year 1982, what is the difference between the Amount of CO2 emissions(kg per 2005 US$ of GDP) of Jordan and Amount of CO2 emissions(kg per 2005 US$ of GDP) of Turkey?
Provide a short and direct response. 0.72. In the year 1983, what is the difference between the Amount of CO2 emissions(kg per 2005 US$ of GDP) in East Asia (all income levels) and Amount of CO2 emissions(kg per 2005 US$ of GDP) in Jordan?
Keep it short and to the point. -0.56. In the year 1983, what is the difference between the Amount of CO2 emissions(kg per 2005 US$ of GDP) in East Asia (all income levels) and Amount of CO2 emissions(kg per 2005 US$ of GDP) in Turkey?
Offer a terse response. 0.35. In the year 1983, what is the difference between the Amount of CO2 emissions(kg per 2005 US$ of GDP) in Jordan and Amount of CO2 emissions(kg per 2005 US$ of GDP) in Turkey?
Ensure brevity in your answer.  0.91. In the year 1984, what is the difference between the Amount of CO2 emissions(kg per 2005 US$ of GDP) of East Asia (all income levels) and Amount of CO2 emissions(kg per 2005 US$ of GDP) of Jordan?
Provide a short and direct response. -0.61. In the year 1984, what is the difference between the Amount of CO2 emissions(kg per 2005 US$ of GDP) of East Asia (all income levels) and Amount of CO2 emissions(kg per 2005 US$ of GDP) of Turkey?
Offer a terse response. 0.36. In the year 1984, what is the difference between the Amount of CO2 emissions(kg per 2005 US$ of GDP) of Jordan and Amount of CO2 emissions(kg per 2005 US$ of GDP) of Turkey?
Keep it short and to the point. 0.97. In the year 1985, what is the difference between the Amount of CO2 emissions(kg per 2005 US$ of GDP) in East Asia (all income levels) and Amount of CO2 emissions(kg per 2005 US$ of GDP) in Jordan?
Offer a very short reply. -0.61. In the year 1985, what is the difference between the Amount of CO2 emissions(kg per 2005 US$ of GDP) of East Asia (all income levels) and Amount of CO2 emissions(kg per 2005 US$ of GDP) of Turkey?
Make the answer very short. 0.32. In the year 1985, what is the difference between the Amount of CO2 emissions(kg per 2005 US$ of GDP) in Jordan and Amount of CO2 emissions(kg per 2005 US$ of GDP) in Turkey?
Provide a succinct answer. 0.92. In the year 1986, what is the difference between the Amount of CO2 emissions(kg per 2005 US$ of GDP) of East Asia (all income levels) and Amount of CO2 emissions(kg per 2005 US$ of GDP) of Jordan?
Your response must be concise. -0.64. In the year 1986, what is the difference between the Amount of CO2 emissions(kg per 2005 US$ of GDP) of East Asia (all income levels) and Amount of CO2 emissions(kg per 2005 US$ of GDP) of Turkey?
Your answer should be very brief. 0.3. In the year 1986, what is the difference between the Amount of CO2 emissions(kg per 2005 US$ of GDP) of Jordan and Amount of CO2 emissions(kg per 2005 US$ of GDP) of Turkey?
Offer a terse response. 0.93. In the year 1987, what is the difference between the Amount of CO2 emissions(kg per 2005 US$ of GDP) in East Asia (all income levels) and Amount of CO2 emissions(kg per 2005 US$ of GDP) in Jordan?
Your answer should be compact. -0.66. In the year 1987, what is the difference between the Amount of CO2 emissions(kg per 2005 US$ of GDP) of East Asia (all income levels) and Amount of CO2 emissions(kg per 2005 US$ of GDP) of Turkey?
Give a very brief answer. 0.28. In the year 1987, what is the difference between the Amount of CO2 emissions(kg per 2005 US$ of GDP) of Jordan and Amount of CO2 emissions(kg per 2005 US$ of GDP) of Turkey?
Make the answer very short. 0.94. What is the ratio of the Amount of CO2 emissions(kg per 2005 US$ of GDP) of East Asia (all income levels) in 1980 to that in 1981?
Give a very brief answer. 1.06. What is the ratio of the Amount of CO2 emissions(kg per 2005 US$ of GDP) in Jordan in 1980 to that in 1981?
Your response must be concise. 0.84. What is the ratio of the Amount of CO2 emissions(kg per 2005 US$ of GDP) of East Asia (all income levels) in 1980 to that in 1982?
Your answer should be compact. 1.06. What is the ratio of the Amount of CO2 emissions(kg per 2005 US$ of GDP) of Jordan in 1980 to that in 1982?
Give a very brief answer. 0.84. What is the ratio of the Amount of CO2 emissions(kg per 2005 US$ of GDP) of Turkey in 1980 to that in 1982?
Keep it short and to the point. 0.95. What is the ratio of the Amount of CO2 emissions(kg per 2005 US$ of GDP) in East Asia (all income levels) in 1980 to that in 1983?
Offer a terse response. 1.07. What is the ratio of the Amount of CO2 emissions(kg per 2005 US$ of GDP) of Jordan in 1980 to that in 1983?
Offer a very short reply. 0.74. What is the ratio of the Amount of CO2 emissions(kg per 2005 US$ of GDP) of Turkey in 1980 to that in 1983?
Your response must be concise. 0.95. What is the ratio of the Amount of CO2 emissions(kg per 2005 US$ of GDP) of East Asia (all income levels) in 1980 to that in 1984?
Provide a succinct answer. 1.05. What is the ratio of the Amount of CO2 emissions(kg per 2005 US$ of GDP) of Jordan in 1980 to that in 1984?
Your response must be concise. 0.7. What is the ratio of the Amount of CO2 emissions(kg per 2005 US$ of GDP) in Turkey in 1980 to that in 1984?
Offer a terse response. 0.96. What is the ratio of the Amount of CO2 emissions(kg per 2005 US$ of GDP) of East Asia (all income levels) in 1980 to that in 1985?
Offer a terse response. 1.07. What is the ratio of the Amount of CO2 emissions(kg per 2005 US$ of GDP) in Jordan in 1980 to that in 1985?
Provide a succinct answer. 0.71. What is the ratio of the Amount of CO2 emissions(kg per 2005 US$ of GDP) in Turkey in 1980 to that in 1985?
Offer a terse response. 0.9. What is the ratio of the Amount of CO2 emissions(kg per 2005 US$ of GDP) of East Asia (all income levels) in 1980 to that in 1986?
Give a very brief answer. 1.08. What is the ratio of the Amount of CO2 emissions(kg per 2005 US$ of GDP) of Jordan in 1980 to that in 1986?
Provide a succinct answer. 0.7. What is the ratio of the Amount of CO2 emissions(kg per 2005 US$ of GDP) of Turkey in 1980 to that in 1986?
Offer a very short reply. 0.88. What is the ratio of the Amount of CO2 emissions(kg per 2005 US$ of GDP) in East Asia (all income levels) in 1980 to that in 1987?
Your response must be concise. 1.09. What is the ratio of the Amount of CO2 emissions(kg per 2005 US$ of GDP) in Jordan in 1980 to that in 1987?
Give a very brief answer. 0.69. What is the ratio of the Amount of CO2 emissions(kg per 2005 US$ of GDP) in Turkey in 1980 to that in 1987?
Your response must be concise. 0.87. What is the ratio of the Amount of CO2 emissions(kg per 2005 US$ of GDP) of East Asia (all income levels) in 1981 to that in 1982?
Your answer should be very brief. 1. What is the ratio of the Amount of CO2 emissions(kg per 2005 US$ of GDP) in Jordan in 1981 to that in 1982?
Your answer should be very brief. 1. What is the ratio of the Amount of CO2 emissions(kg per 2005 US$ of GDP) in Turkey in 1981 to that in 1982?
Offer a terse response. 0.95. What is the ratio of the Amount of CO2 emissions(kg per 2005 US$ of GDP) in East Asia (all income levels) in 1981 to that in 1983?
Offer a very short reply. 1.01. What is the ratio of the Amount of CO2 emissions(kg per 2005 US$ of GDP) in Jordan in 1981 to that in 1983?
Your answer should be compact. 0.87. What is the ratio of the Amount of CO2 emissions(kg per 2005 US$ of GDP) in Turkey in 1981 to that in 1983?
Your response must be concise. 0.96. What is the ratio of the Amount of CO2 emissions(kg per 2005 US$ of GDP) in East Asia (all income levels) in 1981 to that in 1984?
Keep it short and to the point. 1. What is the ratio of the Amount of CO2 emissions(kg per 2005 US$ of GDP) of Jordan in 1981 to that in 1984?
Your answer should be compact. 0.84. What is the ratio of the Amount of CO2 emissions(kg per 2005 US$ of GDP) of Turkey in 1981 to that in 1984?
Your answer should be very brief. 0.97. What is the ratio of the Amount of CO2 emissions(kg per 2005 US$ of GDP) of East Asia (all income levels) in 1981 to that in 1985?
Your answer should be very brief. 1.01. What is the ratio of the Amount of CO2 emissions(kg per 2005 US$ of GDP) in Jordan in 1981 to that in 1985?
Your answer should be compact. 0.85. What is the ratio of the Amount of CO2 emissions(kg per 2005 US$ of GDP) in Turkey in 1981 to that in 1985?
Make the answer very short. 0.91. What is the ratio of the Amount of CO2 emissions(kg per 2005 US$ of GDP) in East Asia (all income levels) in 1981 to that in 1986?
Give a very brief answer. 1.02. What is the ratio of the Amount of CO2 emissions(kg per 2005 US$ of GDP) in Jordan in 1981 to that in 1986?
Keep it short and to the point. 0.83. What is the ratio of the Amount of CO2 emissions(kg per 2005 US$ of GDP) in Turkey in 1981 to that in 1986?
Your response must be concise. 0.88. What is the ratio of the Amount of CO2 emissions(kg per 2005 US$ of GDP) in East Asia (all income levels) in 1981 to that in 1987?
Provide a succinct answer. 1.03. What is the ratio of the Amount of CO2 emissions(kg per 2005 US$ of GDP) in Jordan in 1981 to that in 1987?
Give a very brief answer. 0.82. What is the ratio of the Amount of CO2 emissions(kg per 2005 US$ of GDP) in Turkey in 1981 to that in 1987?
Make the answer very short. 0.87. What is the ratio of the Amount of CO2 emissions(kg per 2005 US$ of GDP) of East Asia (all income levels) in 1982 to that in 1983?
Offer a very short reply. 1.01. What is the ratio of the Amount of CO2 emissions(kg per 2005 US$ of GDP) in Jordan in 1982 to that in 1983?
Provide a succinct answer. 0.87. What is the ratio of the Amount of CO2 emissions(kg per 2005 US$ of GDP) in Turkey in 1982 to that in 1983?
Offer a very short reply. 1.01. What is the ratio of the Amount of CO2 emissions(kg per 2005 US$ of GDP) of Jordan in 1982 to that in 1984?
Your answer should be very brief. 0.83. What is the ratio of the Amount of CO2 emissions(kg per 2005 US$ of GDP) in Turkey in 1982 to that in 1984?
Give a very brief answer. 1.02. What is the ratio of the Amount of CO2 emissions(kg per 2005 US$ of GDP) of East Asia (all income levels) in 1982 to that in 1985?
Offer a very short reply. 1.01. What is the ratio of the Amount of CO2 emissions(kg per 2005 US$ of GDP) of Jordan in 1982 to that in 1985?
Offer a very short reply. 0.84. What is the ratio of the Amount of CO2 emissions(kg per 2005 US$ of GDP) of Turkey in 1982 to that in 1985?
Keep it short and to the point. 0.95. What is the ratio of the Amount of CO2 emissions(kg per 2005 US$ of GDP) of East Asia (all income levels) in 1982 to that in 1986?
Ensure brevity in your answer.  1.02. What is the ratio of the Amount of CO2 emissions(kg per 2005 US$ of GDP) in Jordan in 1982 to that in 1986?
Your answer should be very brief. 0.83. What is the ratio of the Amount of CO2 emissions(kg per 2005 US$ of GDP) in East Asia (all income levels) in 1982 to that in 1987?
Make the answer very short. 1.03. What is the ratio of the Amount of CO2 emissions(kg per 2005 US$ of GDP) in Jordan in 1982 to that in 1987?
Your answer should be very brief. 0.82. What is the ratio of the Amount of CO2 emissions(kg per 2005 US$ of GDP) of Turkey in 1982 to that in 1987?
Give a very brief answer. 0.92. What is the ratio of the Amount of CO2 emissions(kg per 2005 US$ of GDP) in Jordan in 1983 to that in 1984?
Provide a short and direct response. 0.96. What is the ratio of the Amount of CO2 emissions(kg per 2005 US$ of GDP) of Turkey in 1983 to that in 1984?
Offer a very short reply. 1.01. What is the ratio of the Amount of CO2 emissions(kg per 2005 US$ of GDP) in Turkey in 1983 to that in 1985?
Provide a succinct answer. 0.94. What is the ratio of the Amount of CO2 emissions(kg per 2005 US$ of GDP) in East Asia (all income levels) in 1983 to that in 1986?
Keep it short and to the point. 1.01. What is the ratio of the Amount of CO2 emissions(kg per 2005 US$ of GDP) of Jordan in 1983 to that in 1986?
Ensure brevity in your answer.  0.95. What is the ratio of the Amount of CO2 emissions(kg per 2005 US$ of GDP) in Turkey in 1983 to that in 1986?
Offer a terse response. 0.92. What is the ratio of the Amount of CO2 emissions(kg per 2005 US$ of GDP) of East Asia (all income levels) in 1983 to that in 1987?
Make the answer very short. 1.02. What is the ratio of the Amount of CO2 emissions(kg per 2005 US$ of GDP) in Jordan in 1983 to that in 1987?
Offer a terse response. 0.94. What is the ratio of the Amount of CO2 emissions(kg per 2005 US$ of GDP) in Turkey in 1983 to that in 1987?
Your answer should be compact. 0.91. What is the ratio of the Amount of CO2 emissions(kg per 2005 US$ of GDP) of East Asia (all income levels) in 1984 to that in 1985?
Make the answer very short. 1.01. What is the ratio of the Amount of CO2 emissions(kg per 2005 US$ of GDP) in Jordan in 1984 to that in 1985?
Keep it short and to the point. 1.01. What is the ratio of the Amount of CO2 emissions(kg per 2005 US$ of GDP) of Turkey in 1984 to that in 1985?
Your answer should be very brief. 0.94. What is the ratio of the Amount of CO2 emissions(kg per 2005 US$ of GDP) in East Asia (all income levels) in 1984 to that in 1986?
Provide a succinct answer. 1.02. What is the ratio of the Amount of CO2 emissions(kg per 2005 US$ of GDP) in Turkey in 1984 to that in 1986?
Your response must be concise. 0.91. What is the ratio of the Amount of CO2 emissions(kg per 2005 US$ of GDP) of East Asia (all income levels) in 1984 to that in 1987?
Give a very brief answer. 1.03. What is the ratio of the Amount of CO2 emissions(kg per 2005 US$ of GDP) of Jordan in 1984 to that in 1987?
Keep it short and to the point. 0.98. What is the ratio of the Amount of CO2 emissions(kg per 2005 US$ of GDP) of Turkey in 1984 to that in 1987?
Your answer should be very brief. 0.9. What is the ratio of the Amount of CO2 emissions(kg per 2005 US$ of GDP) of East Asia (all income levels) in 1985 to that in 1986?
Your answer should be very brief. 1.01. What is the ratio of the Amount of CO2 emissions(kg per 2005 US$ of GDP) of Jordan in 1985 to that in 1986?
Keep it short and to the point. 0.98. What is the ratio of the Amount of CO2 emissions(kg per 2005 US$ of GDP) of Turkey in 1985 to that in 1986?
Your answer should be very brief. 0.98. What is the ratio of the Amount of CO2 emissions(kg per 2005 US$ of GDP) of East Asia (all income levels) in 1985 to that in 1987?
Give a very brief answer. 1.02. What is the ratio of the Amount of CO2 emissions(kg per 2005 US$ of GDP) of Jordan in 1985 to that in 1987?
Your answer should be compact. 0.97. What is the ratio of the Amount of CO2 emissions(kg per 2005 US$ of GDP) of Turkey in 1985 to that in 1987?
Provide a short and direct response. 0.96. What is the ratio of the Amount of CO2 emissions(kg per 2005 US$ of GDP) of East Asia (all income levels) in 1986 to that in 1987?
Provide a succinct answer. 1.01. What is the ratio of the Amount of CO2 emissions(kg per 2005 US$ of GDP) in Jordan in 1986 to that in 1987?
Your answer should be very brief. 0.99. What is the ratio of the Amount of CO2 emissions(kg per 2005 US$ of GDP) in Turkey in 1986 to that in 1987?
Offer a terse response. 0.99. What is the difference between the highest and the second highest Amount of CO2 emissions(kg per 2005 US$ of GDP) in East Asia (all income levels)?
Offer a very short reply. 0.05. What is the difference between the highest and the second highest Amount of CO2 emissions(kg per 2005 US$ of GDP) of Jordan?
Keep it short and to the point. 0.02. What is the difference between the highest and the second highest Amount of CO2 emissions(kg per 2005 US$ of GDP) of Turkey?
Provide a short and direct response. 0.01. What is the difference between the highest and the lowest Amount of CO2 emissions(kg per 2005 US$ of GDP) in East Asia (all income levels)?
Your answer should be compact. 0.07. What is the difference between the highest and the lowest Amount of CO2 emissions(kg per 2005 US$ of GDP) in Jordan?
Keep it short and to the point. 0.45. What is the difference between the highest and the lowest Amount of CO2 emissions(kg per 2005 US$ of GDP) of Turkey?
Give a very brief answer. 0.07. 